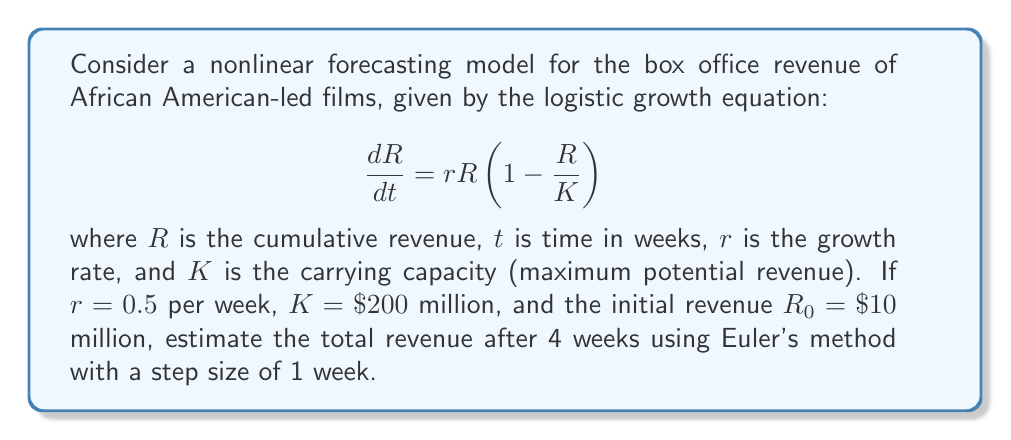Teach me how to tackle this problem. To solve this problem, we'll use Euler's method to approximate the solution of the logistic growth equation:

1) Euler's method is given by: $R_{n+1} = R_n + h \cdot f(t_n, R_n)$
   where $h$ is the step size (1 week in this case) and $f(t, R) = rR(1 - \frac{R}{K})$

2) Given: $r = 0.5$, $K = 200$, $R_0 = 10$, $h = 1$, and we need to iterate 4 times

3) Let's calculate step by step:

   For $n = 0$:
   $R_1 = 10 + 1 \cdot (0.5 \cdot 10 \cdot (1 - \frac{10}{200})) = 10 + 4.75 = 14.75$

   For $n = 1$:
   $R_2 = 14.75 + 1 \cdot (0.5 \cdot 14.75 \cdot (1 - \frac{14.75}{200})) = 14.75 + 6.53 = 21.28$

   For $n = 2$:
   $R_3 = 21.28 + 1 \cdot (0.5 \cdot 21.28 \cdot (1 - \frac{21.28}{200})) = 21.28 + 8.67 = 29.95$

   For $n = 3$:
   $R_4 = 29.95 + 1 \cdot (0.5 \cdot 29.95 \cdot (1 - \frac{29.95}{200})) = 29.95 + 11.08 = 41.03$

4) Therefore, the estimated total revenue after 4 weeks is approximately $41.03 million.
Answer: $41.03 million 